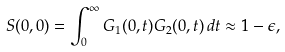Convert formula to latex. <formula><loc_0><loc_0><loc_500><loc_500>S ( 0 , 0 ) = \int _ { 0 } ^ { \infty } G _ { 1 } ( 0 , t ) G _ { 2 } ( 0 , t ) \, d t \approx 1 - \epsilon ,</formula> 